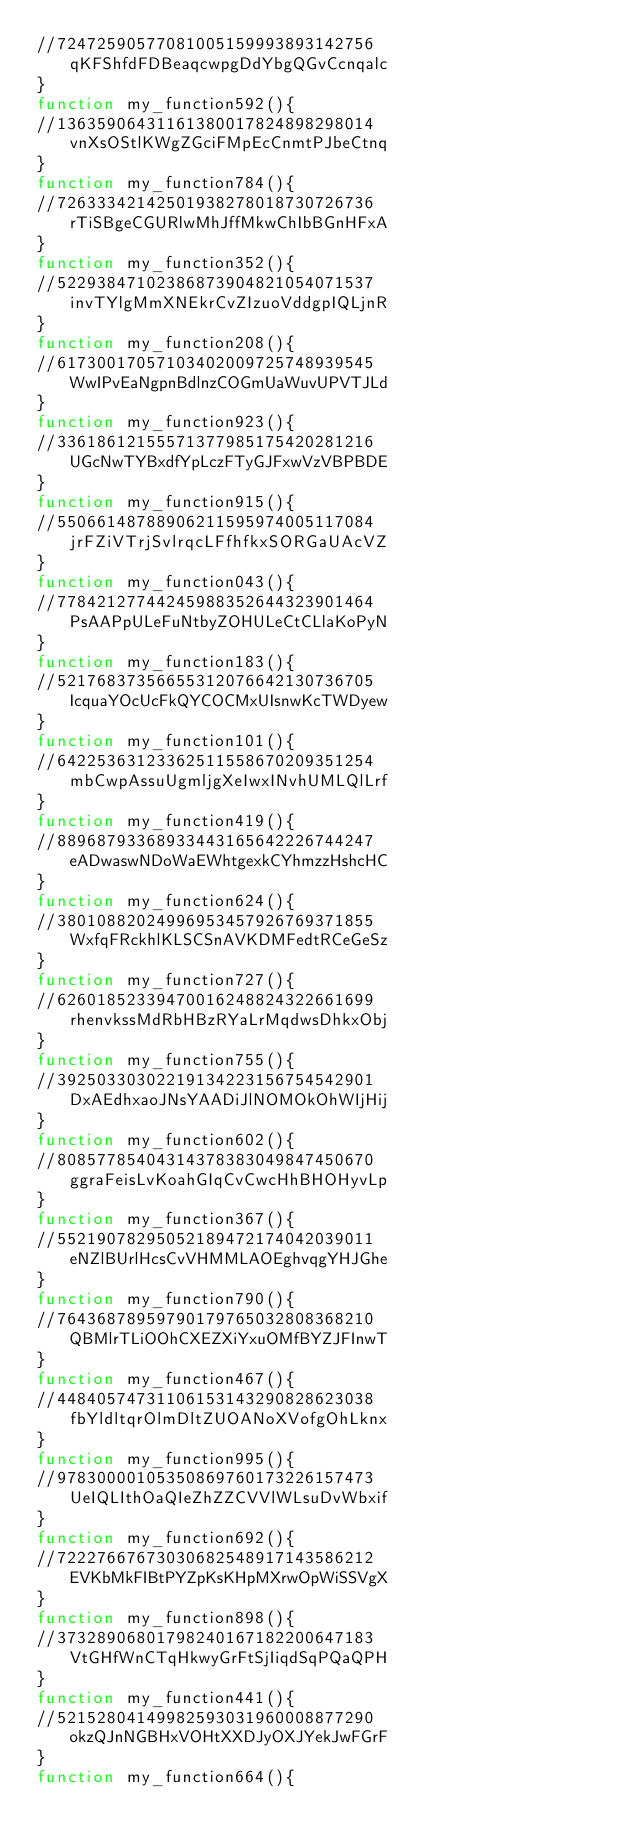Convert code to text. <code><loc_0><loc_0><loc_500><loc_500><_JavaScript_>//72472590577081005159993893142756qKFShfdFDBeaqcwpgDdYbgQGvCcnqalc
}
function my_function592(){ 
//13635906431161380017824898298014vnXsOStlKWgZGciFMpEcCnmtPJbeCtnq
}
function my_function784(){ 
//72633342142501938278018730726736rTiSBgeCGURlwMhJffMkwChIbBGnHFxA
}
function my_function352(){ 
//52293847102386873904821054071537invTYlgMmXNEkrCvZIzuoVddgpIQLjnR
}
function my_function208(){ 
//61730017057103402009725748939545WwIPvEaNgpnBdlnzCOGmUaWuvUPVTJLd
}
function my_function923(){ 
//33618612155571377985175420281216UGcNwTYBxdfYpLczFTyGJFxwVzVBPBDE
}
function my_function915(){ 
//55066148788906211595974005117084jrFZiVTrjSvlrqcLFfhfkxSORGaUAcVZ
}
function my_function043(){ 
//77842127744245988352644323901464PsAAPpULeFuNtbyZOHULeCtCLlaKoPyN
}
function my_function183(){ 
//52176837356655312076642130736705IcquaYOcUcFkQYCOCMxUIsnwKcTWDyew
}
function my_function101(){ 
//64225363123362511558670209351254mbCwpAssuUgmljgXeIwxINvhUMLQlLrf
}
function my_function419(){ 
//88968793368933443165642226744247eADwaswNDoWaEWhtgexkCYhmzzHshcHC
}
function my_function624(){ 
//38010882024996953457926769371855WxfqFRckhlKLSCSnAVKDMFedtRCeGeSz
}
function my_function727(){ 
//62601852339470016248824322661699rhenvkssMdRbHBzRYaLrMqdwsDhkxObj
}
function my_function755(){ 
//39250330302219134223156754542901DxAEdhxaoJNsYAADiJlNOMOkOhWIjHij
}
function my_function602(){ 
//80857785404314378383049847450670ggraFeisLvKoahGIqCvCwcHhBHOHyvLp
}
function my_function367(){ 
//55219078295052189472174042039011eNZlBUrlHcsCvVHMMLAOEghvqgYHJGhe
}
function my_function790(){ 
//76436878959790179765032808368210QBMlrTLiOOhCXEZXiYxuOMfBYZJFInwT
}
function my_function467(){ 
//44840574731106153143290828623038fbYldltqrOlmDltZUOANoXVofgOhLknx
}
function my_function995(){ 
//97830000105350869760173226157473UeIQLIthOaQIeZhZZCVVlWLsuDvWbxif
}
function my_function692(){ 
//72227667673030682548917143586212EVKbMkFIBtPYZpKsKHpMXrwOpWiSSVgX
}
function my_function898(){ 
//37328906801798240167182200647183VtGHfWnCTqHkwyGrFtSjIiqdSqPQaQPH
}
function my_function441(){ 
//52152804149982593031960008877290okzQJnNGBHxVOHtXXDJyOXJYekJwFGrF
}
function my_function664(){ </code> 